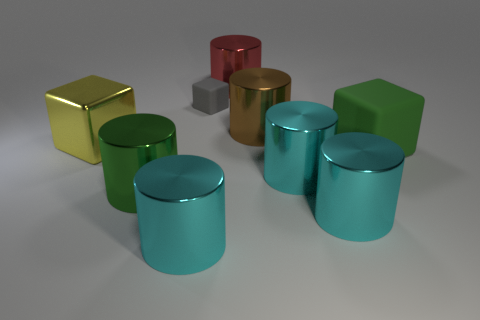Subtract all large cubes. How many cubes are left? 1 Subtract all blue blocks. How many cyan cylinders are left? 3 Subtract 2 cylinders. How many cylinders are left? 4 Subtract all brown cylinders. How many cylinders are left? 5 Subtract all blocks. How many objects are left? 6 Subtract all gray rubber blocks. Subtract all red metal cylinders. How many objects are left? 7 Add 3 tiny gray rubber things. How many tiny gray rubber things are left? 4 Add 4 gray matte things. How many gray matte things exist? 5 Subtract 0 red spheres. How many objects are left? 9 Subtract all yellow cylinders. Subtract all red spheres. How many cylinders are left? 6 